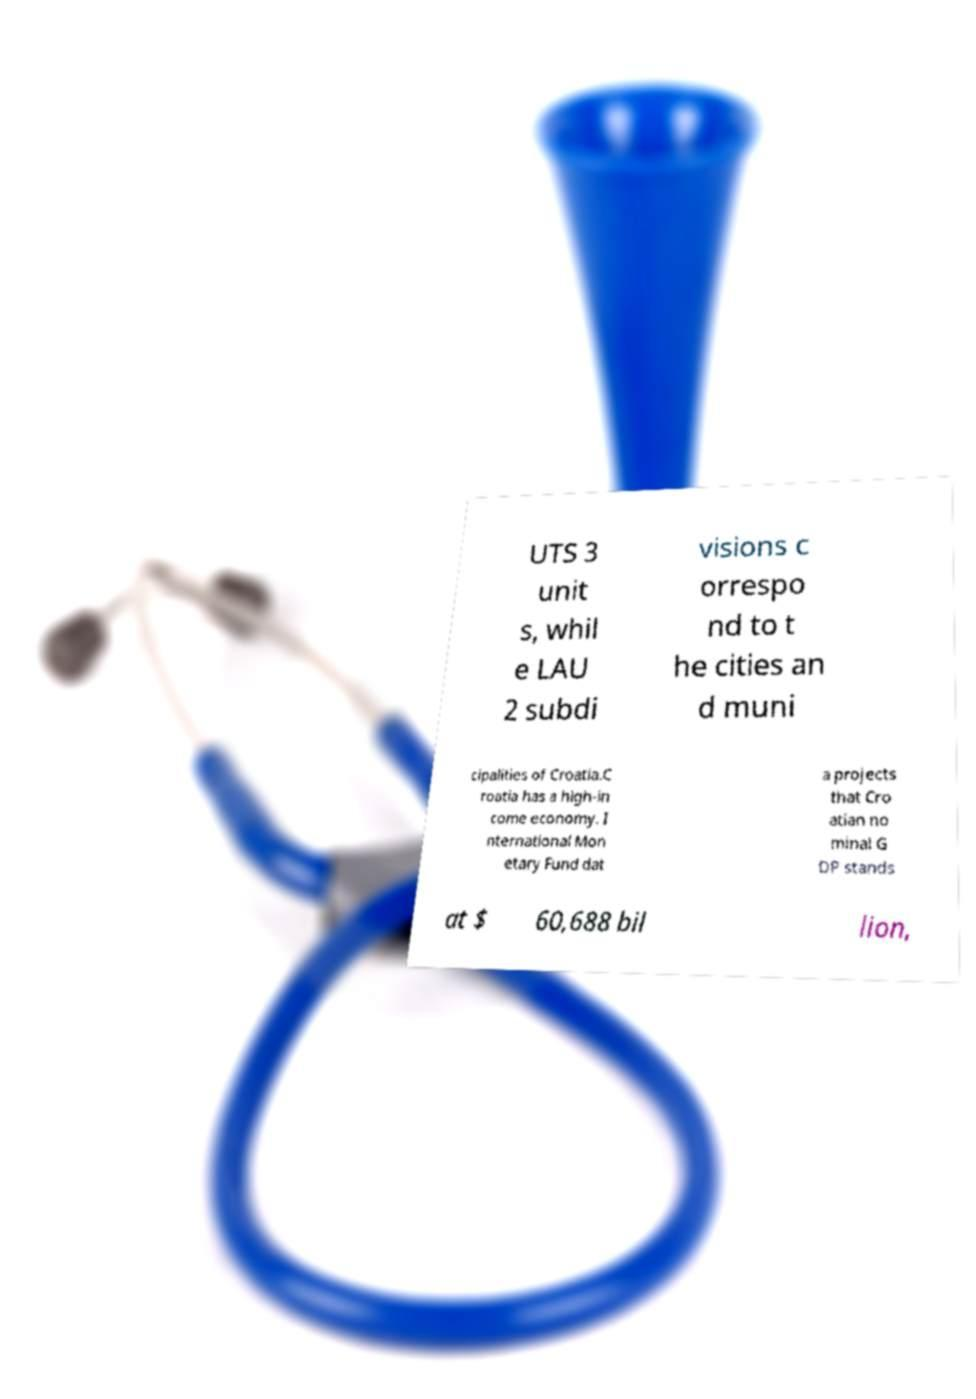For documentation purposes, I need the text within this image transcribed. Could you provide that? UTS 3 unit s, whil e LAU 2 subdi visions c orrespo nd to t he cities an d muni cipalities of Croatia.C roatia has a high-in come economy. I nternational Mon etary Fund dat a projects that Cro atian no minal G DP stands at $ 60,688 bil lion, 